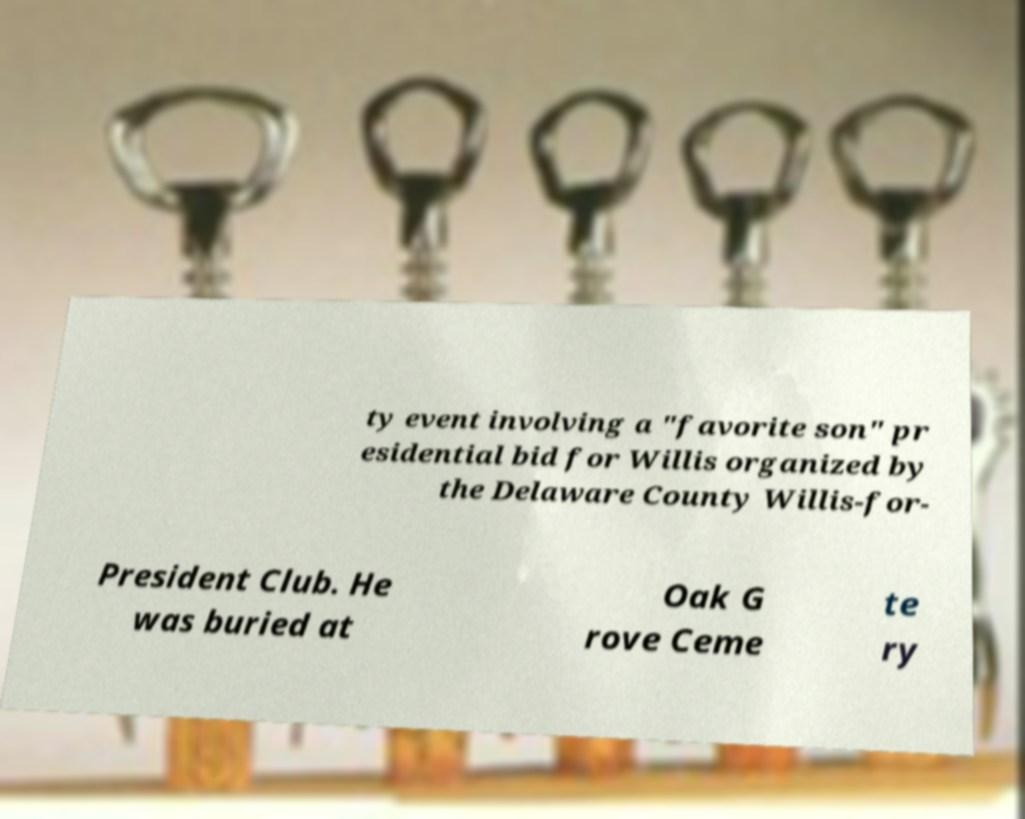For documentation purposes, I need the text within this image transcribed. Could you provide that? ty event involving a "favorite son" pr esidential bid for Willis organized by the Delaware County Willis-for- President Club. He was buried at Oak G rove Ceme te ry 